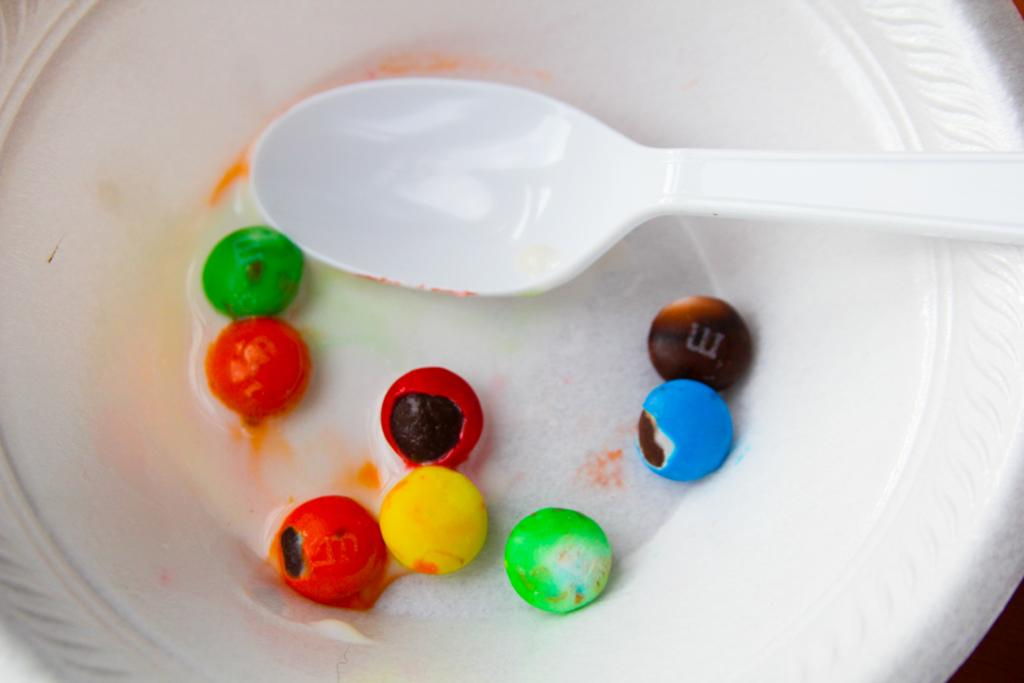What is present on the plate in the image? The facts do not specify what is on the plate. What utensil can be seen in the image? There is a spoon in the image. What type of valuable stones are depicted in the image? There are gems in the image. What type of flag is being waved in the image? There is no flag present in the image. Can you hear the sound of someone crying in the image? The image is silent, and there is no indication of any sound, including crying. 